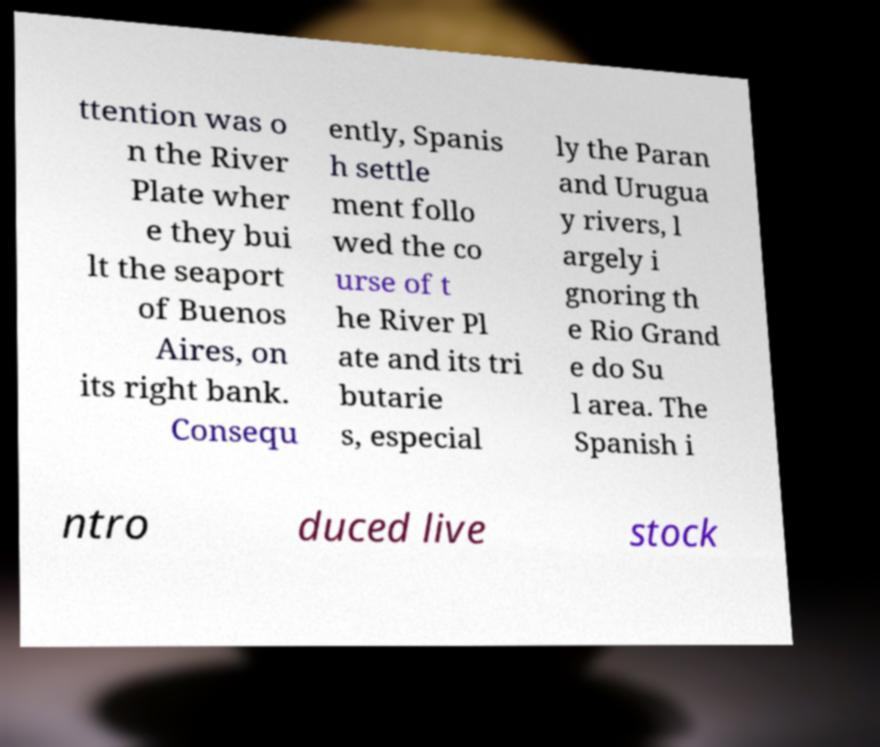For documentation purposes, I need the text within this image transcribed. Could you provide that? ttention was o n the River Plate wher e they bui lt the seaport of Buenos Aires, on its right bank. Consequ ently, Spanis h settle ment follo wed the co urse of t he River Pl ate and its tri butarie s, especial ly the Paran and Urugua y rivers, l argely i gnoring th e Rio Grand e do Su l area. The Spanish i ntro duced live stock 